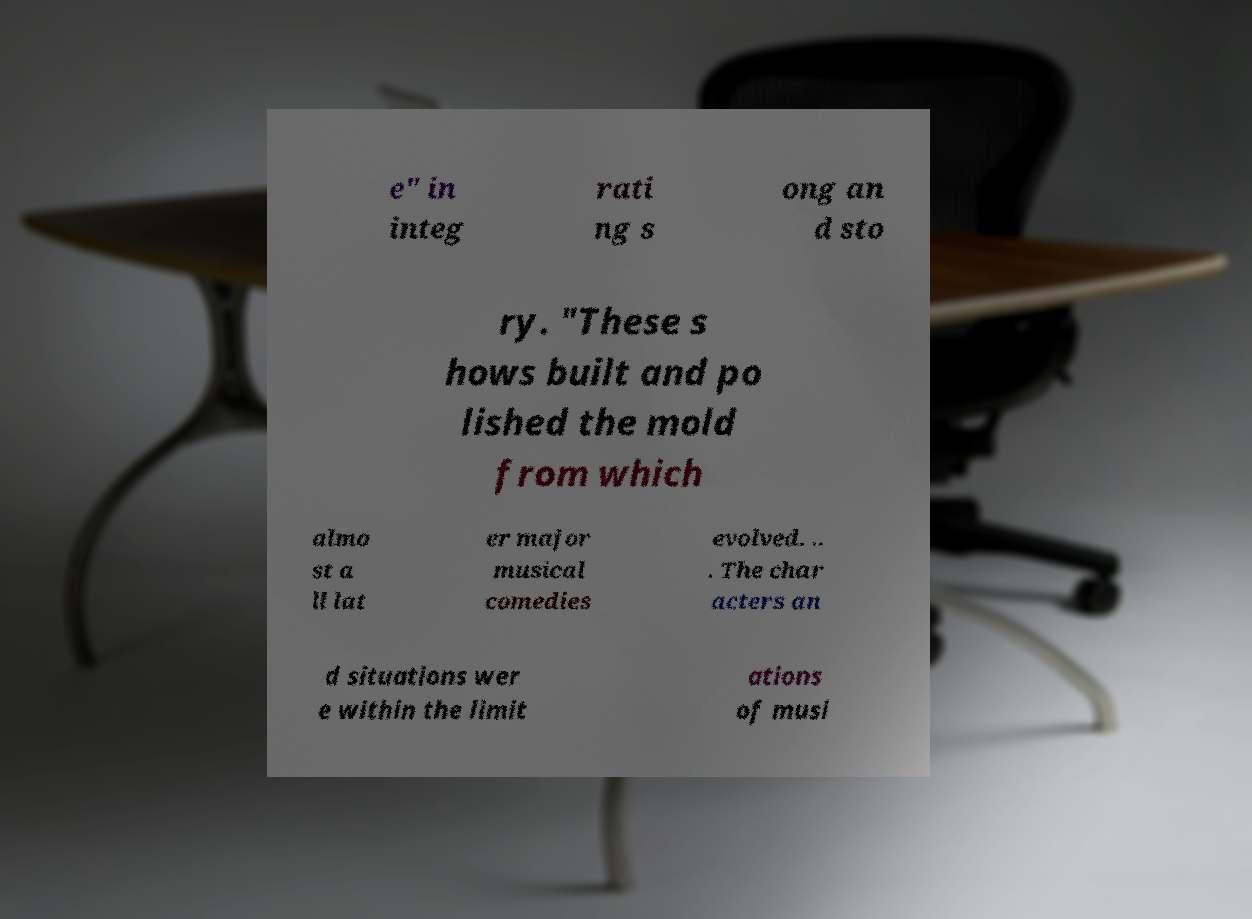For documentation purposes, I need the text within this image transcribed. Could you provide that? e" in integ rati ng s ong an d sto ry. "These s hows built and po lished the mold from which almo st a ll lat er major musical comedies evolved. .. . The char acters an d situations wer e within the limit ations of musi 